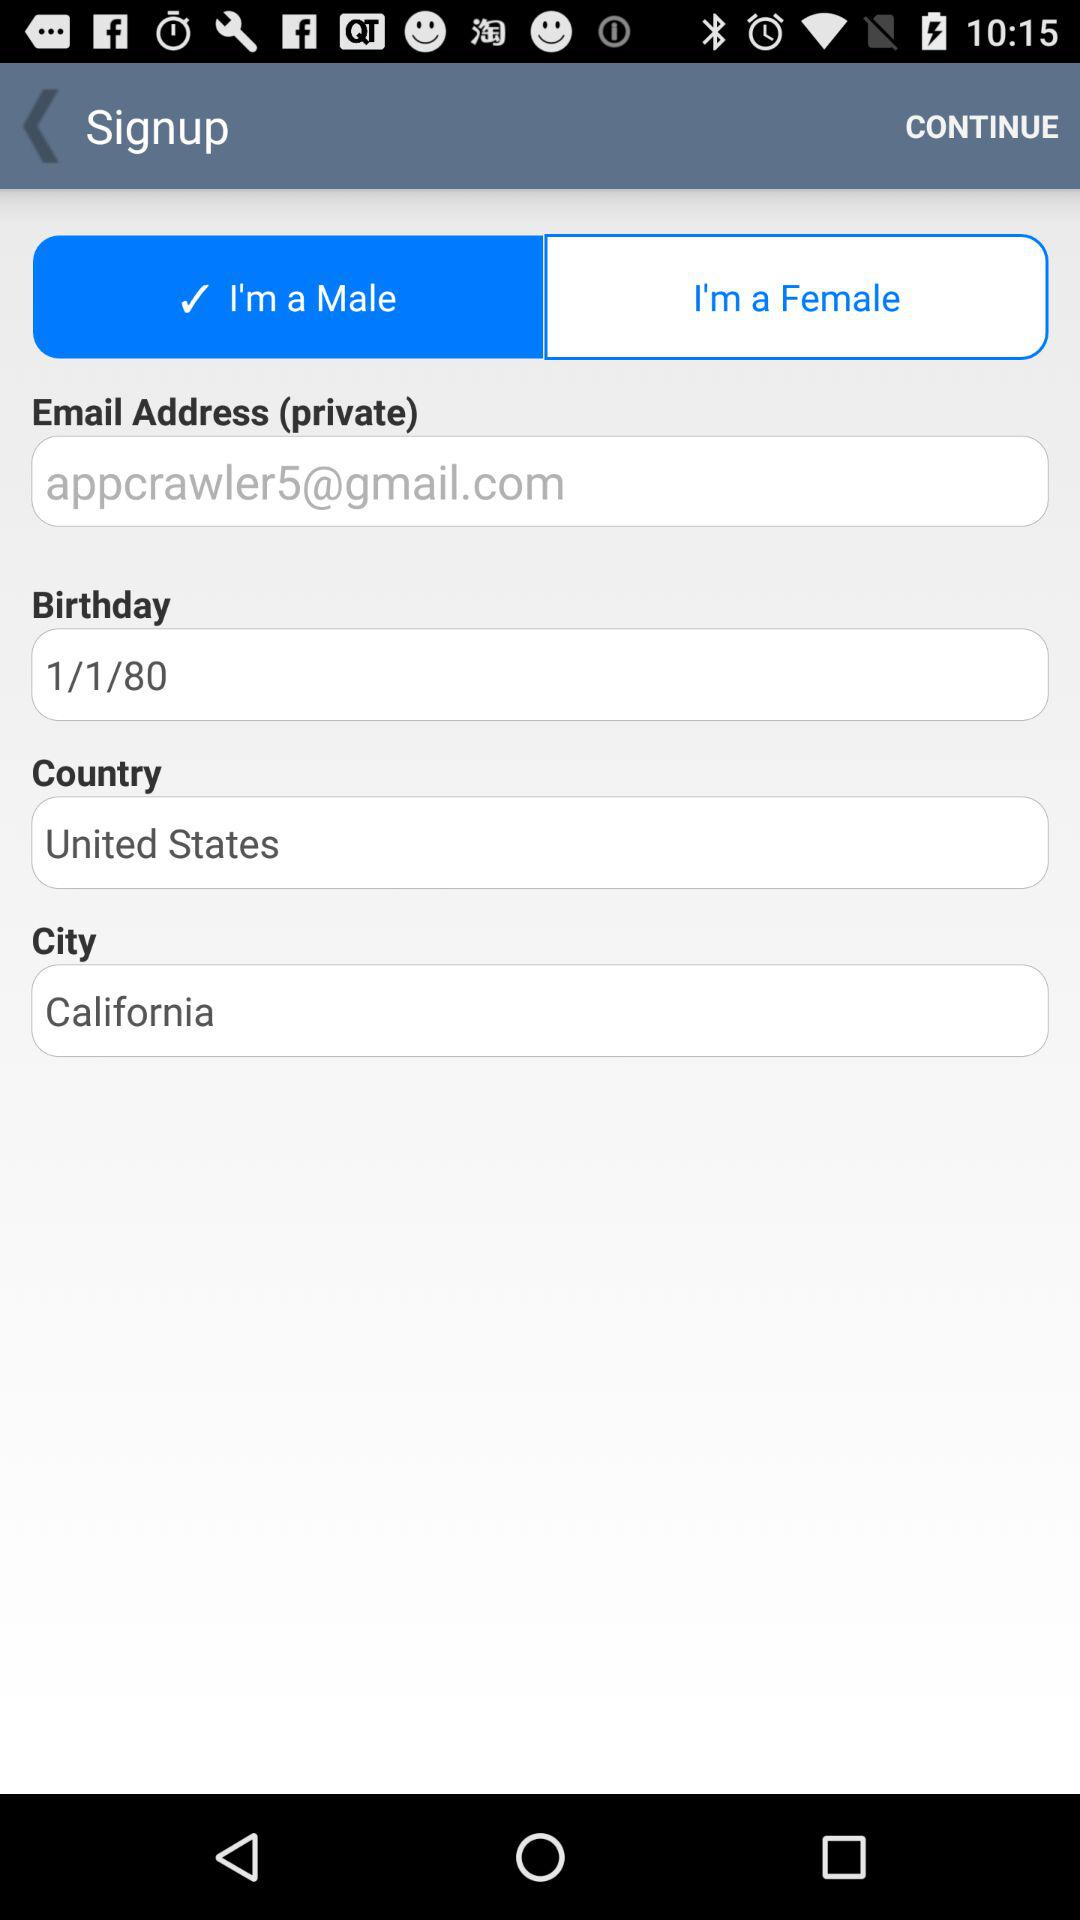What is the gender of the user? The gender of the user is male. 